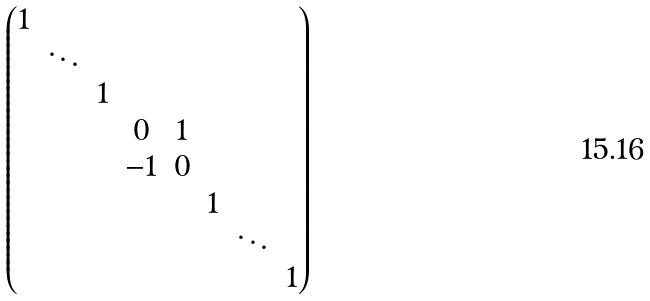<formula> <loc_0><loc_0><loc_500><loc_500>\begin{pmatrix} 1 \\ & \ddots \\ & & 1 \\ & & & 0 & 1 \\ & & & - 1 & 0 \\ & & & & & 1 \\ & & & & & & \ddots \\ & & & & & & & 1 \end{pmatrix}</formula> 